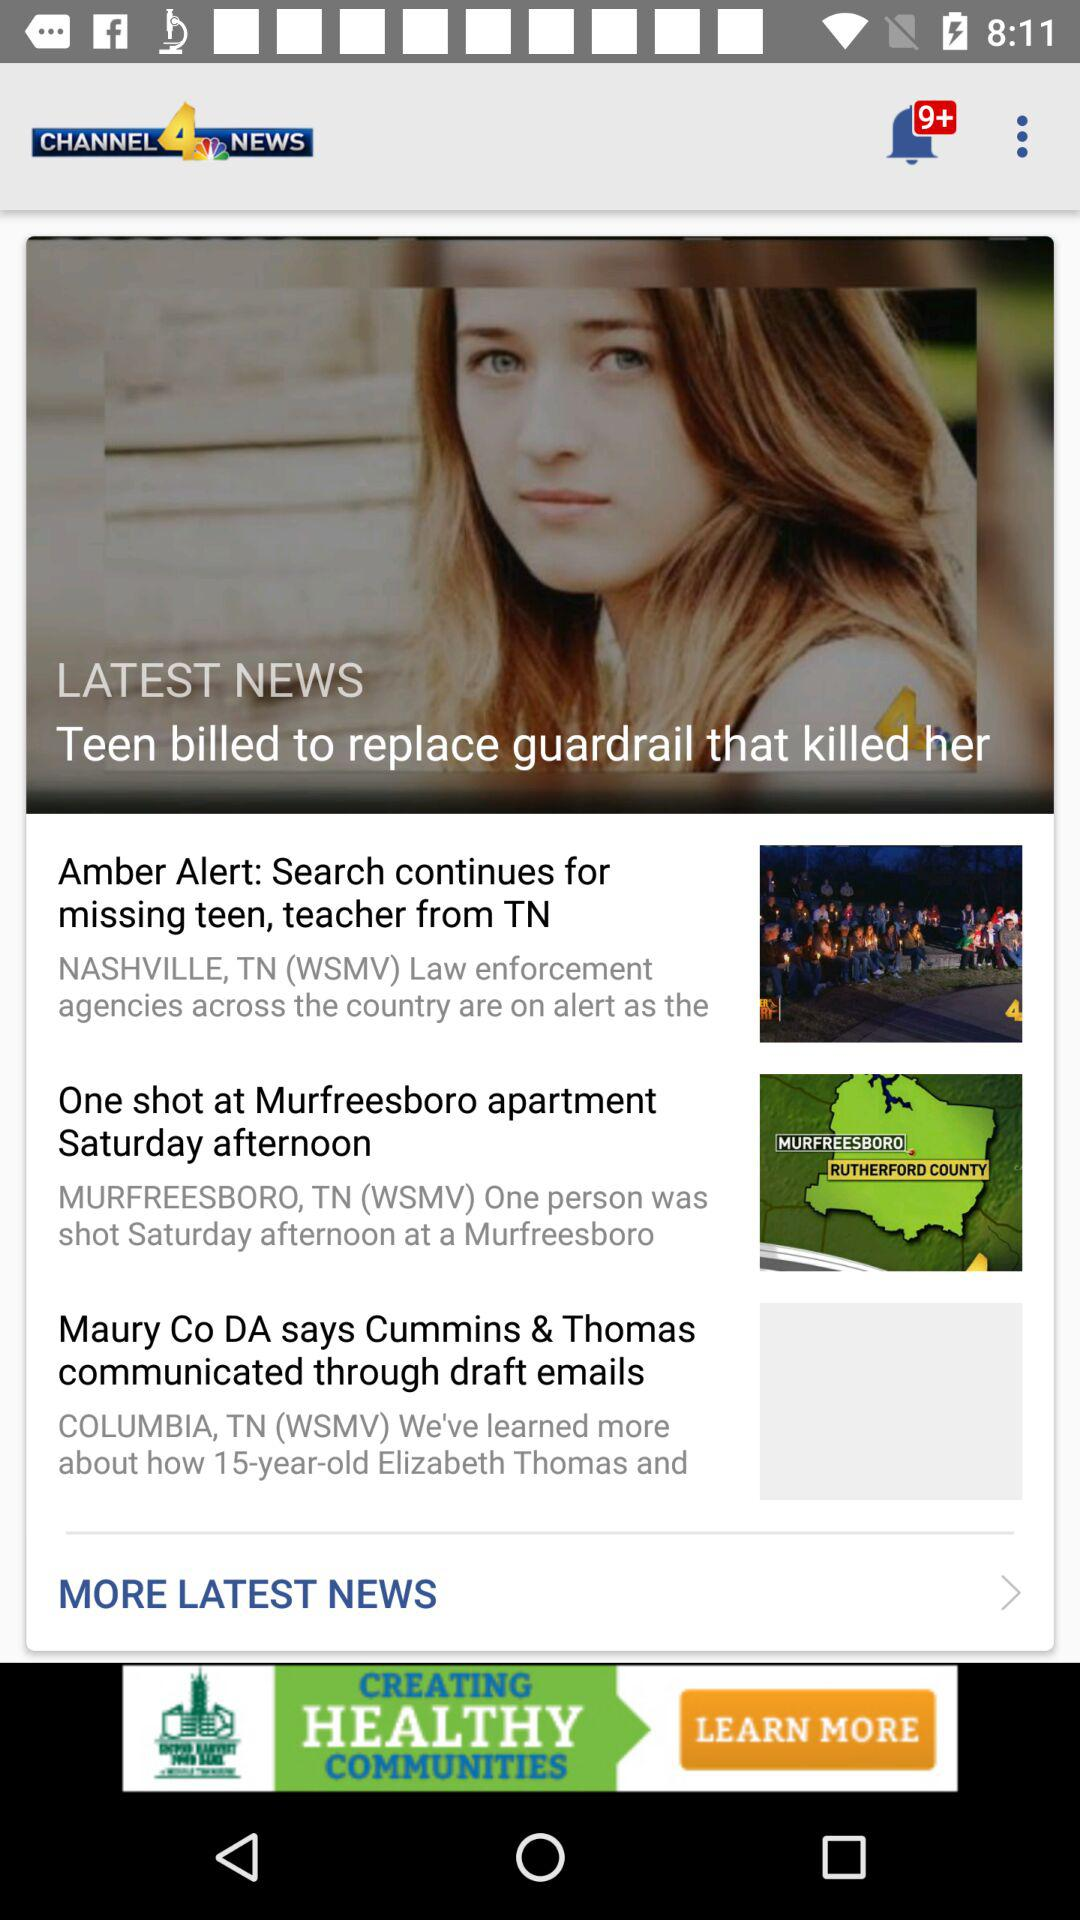How many stories are there in the news feed?
Answer the question using a single word or phrase. 3 